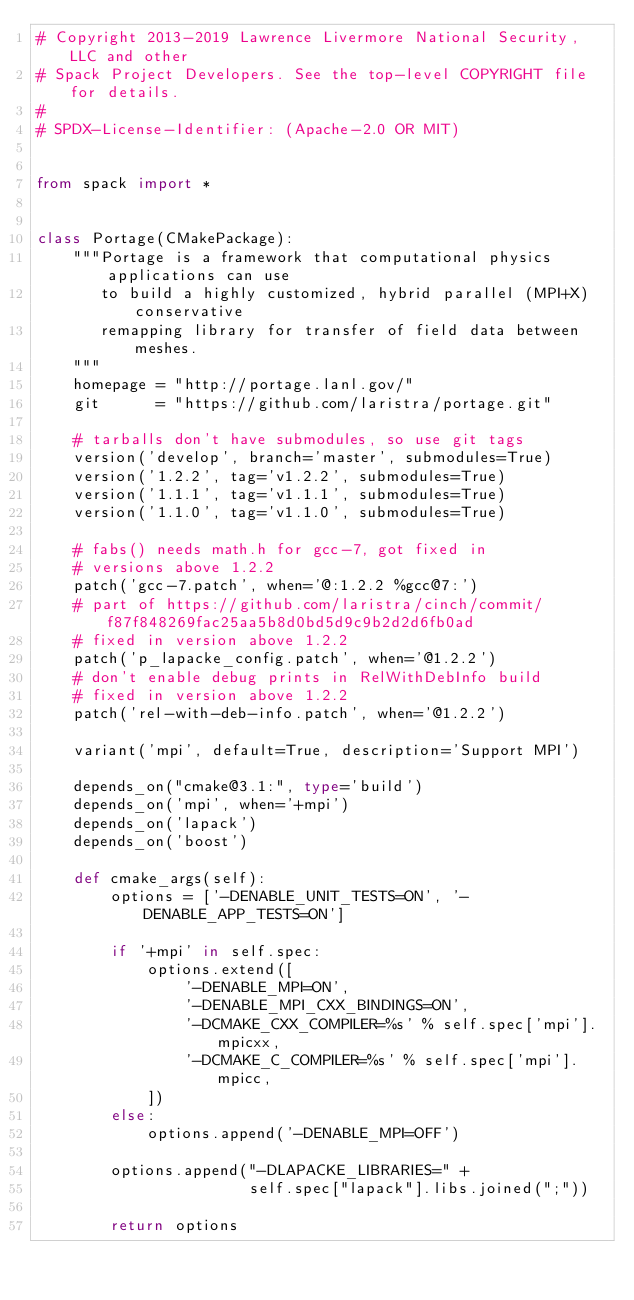<code> <loc_0><loc_0><loc_500><loc_500><_Python_># Copyright 2013-2019 Lawrence Livermore National Security, LLC and other
# Spack Project Developers. See the top-level COPYRIGHT file for details.
#
# SPDX-License-Identifier: (Apache-2.0 OR MIT)


from spack import *


class Portage(CMakePackage):
    """Portage is a framework that computational physics applications can use
       to build a highly customized, hybrid parallel (MPI+X) conservative
       remapping library for transfer of field data between meshes.
    """
    homepage = "http://portage.lanl.gov/"
    git      = "https://github.com/laristra/portage.git"

    # tarballs don't have submodules, so use git tags
    version('develop', branch='master', submodules=True)
    version('1.2.2', tag='v1.2.2', submodules=True)
    version('1.1.1', tag='v1.1.1', submodules=True)
    version('1.1.0', tag='v1.1.0', submodules=True)

    # fabs() needs math.h for gcc-7, got fixed in
    # versions above 1.2.2
    patch('gcc-7.patch', when='@:1.2.2 %gcc@7:')
    # part of https://github.com/laristra/cinch/commit/f87f848269fac25aa5b8d0bd5d9c9b2d2d6fb0ad
    # fixed in version above 1.2.2
    patch('p_lapacke_config.patch', when='@1.2.2')
    # don't enable debug prints in RelWithDebInfo build
    # fixed in version above 1.2.2
    patch('rel-with-deb-info.patch', when='@1.2.2')

    variant('mpi', default=True, description='Support MPI')

    depends_on("cmake@3.1:", type='build')
    depends_on('mpi', when='+mpi')
    depends_on('lapack')
    depends_on('boost')

    def cmake_args(self):
        options = ['-DENABLE_UNIT_TESTS=ON', '-DENABLE_APP_TESTS=ON']

        if '+mpi' in self.spec:
            options.extend([
                '-DENABLE_MPI=ON',
                '-DENABLE_MPI_CXX_BINDINGS=ON',
                '-DCMAKE_CXX_COMPILER=%s' % self.spec['mpi'].mpicxx,
                '-DCMAKE_C_COMPILER=%s' % self.spec['mpi'].mpicc,
            ])
        else:
            options.append('-DENABLE_MPI=OFF')

        options.append("-DLAPACKE_LIBRARIES=" +
                       self.spec["lapack"].libs.joined(";"))

        return options
</code> 